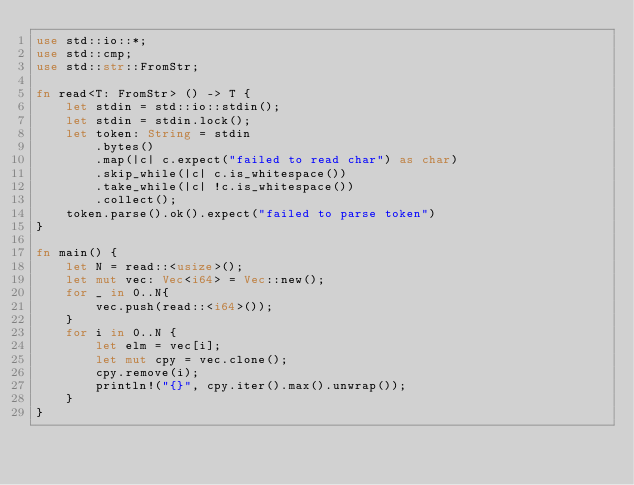<code> <loc_0><loc_0><loc_500><loc_500><_Rust_>use std::io::*;
use std::cmp;
use std::str::FromStr;

fn read<T: FromStr> () -> T {
    let stdin = std::io::stdin();
    let stdin = stdin.lock();
    let token: String = stdin
        .bytes()
        .map(|c| c.expect("failed to read char") as char)
        .skip_while(|c| c.is_whitespace())
        .take_while(|c| !c.is_whitespace())
        .collect();
    token.parse().ok().expect("failed to parse token")
}

fn main() {
    let N = read::<usize>();
    let mut vec: Vec<i64> = Vec::new();
    for _ in 0..N{
        vec.push(read::<i64>());
    }
    for i in 0..N {
        let elm = vec[i];
        let mut cpy = vec.clone();
        cpy.remove(i);
        println!("{}", cpy.iter().max().unwrap());
    }
}

</code> 